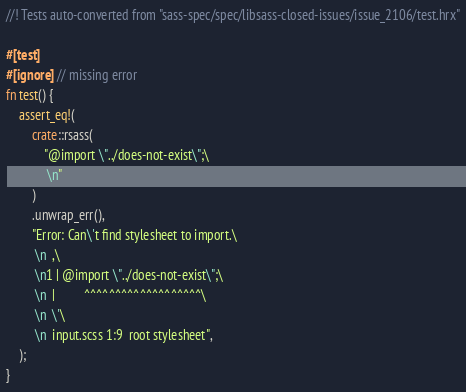Convert code to text. <code><loc_0><loc_0><loc_500><loc_500><_Rust_>//! Tests auto-converted from "sass-spec/spec/libsass-closed-issues/issue_2106/test.hrx"

#[test]
#[ignore] // missing error
fn test() {
    assert_eq!(
        crate::rsass(
            "@import \"../does-not-exist\";\
             \n"
        )
        .unwrap_err(),
        "Error: Can\'t find stylesheet to import.\
         \n  ,\
         \n1 | @import \"../does-not-exist\";\
         \n  |         ^^^^^^^^^^^^^^^^^^^\
         \n  \'\
         \n  input.scss 1:9  root stylesheet",
    );
}
</code> 